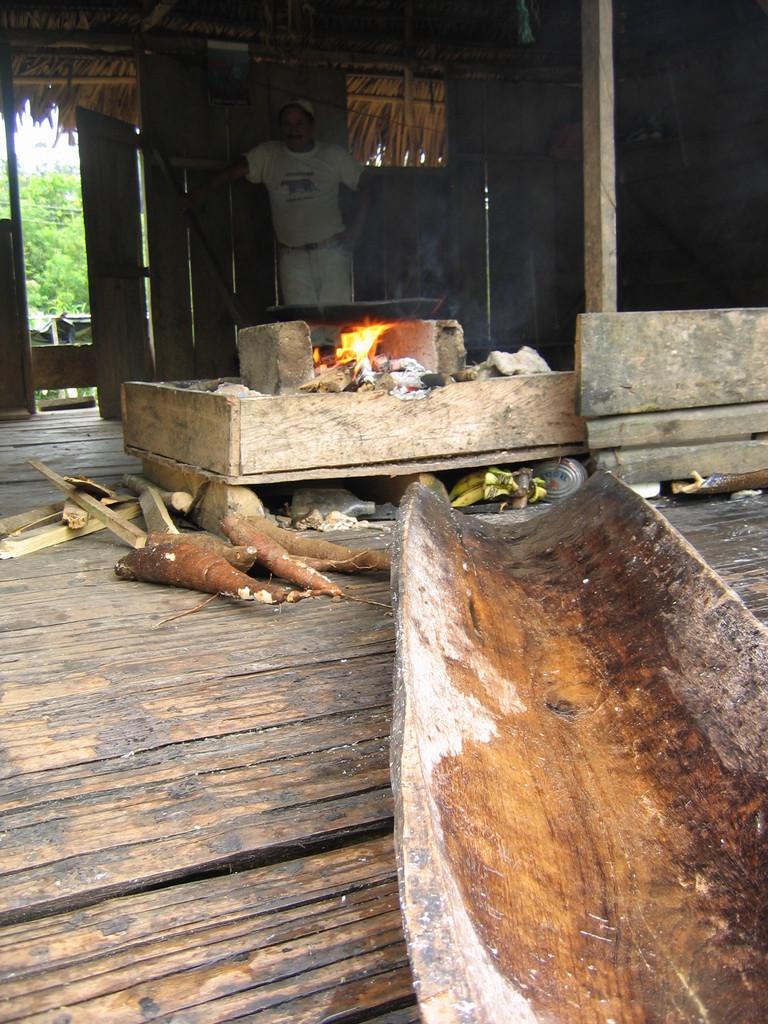What is the main subject of the image? There is a person standing in the image. Can you describe the person's attire? The person is wearing clothes and a cap. What else can be seen in the image besides the person? There are vegetables, a wooden surface, a flame, a pole, a door, and trees visible outside the door. What is the person standing near? The person is standing near a wooden surface. What is the source of light in the image? The flame in the image is the source of light. What type of health benefits can be gained from the can in the image? There is no can present in the image, so it is not possible to determine any health benefits. How many stars can be seen in the image? There are no stars visible in the image. 